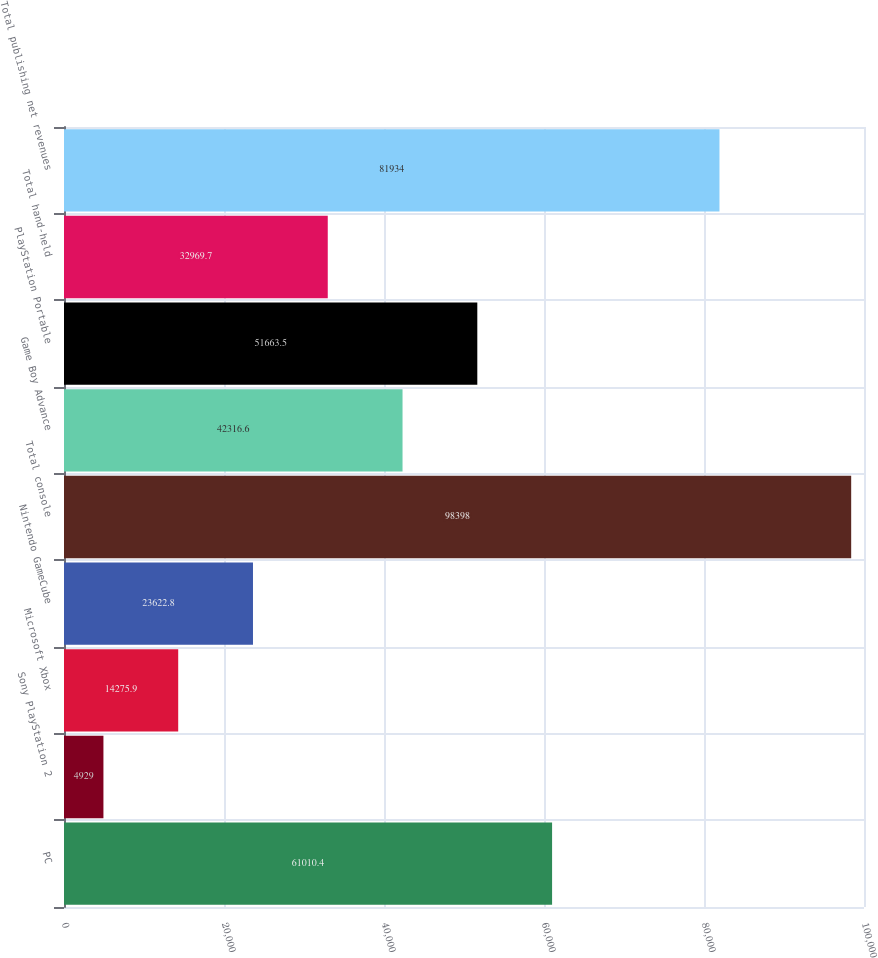<chart> <loc_0><loc_0><loc_500><loc_500><bar_chart><fcel>PC<fcel>Sony PlayStation 2<fcel>Microsoft Xbox<fcel>Nintendo GameCube<fcel>Total console<fcel>Game Boy Advance<fcel>PlayStation Portable<fcel>Total hand-held<fcel>Total publishing net revenues<nl><fcel>61010.4<fcel>4929<fcel>14275.9<fcel>23622.8<fcel>98398<fcel>42316.6<fcel>51663.5<fcel>32969.7<fcel>81934<nl></chart> 